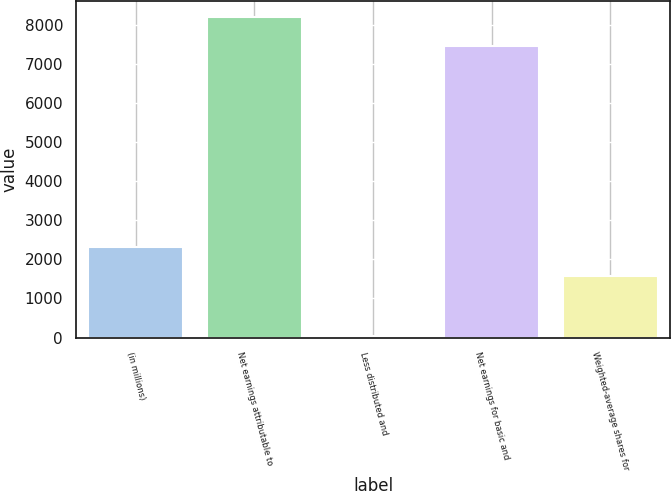<chart> <loc_0><loc_0><loc_500><loc_500><bar_chart><fcel>(in millions)<fcel>Net earnings attributable to<fcel>Less distributed and<fcel>Net earnings for basic and<fcel>Weighted-average shares for<nl><fcel>2311.9<fcel>8204.9<fcel>34<fcel>7459<fcel>1566<nl></chart> 